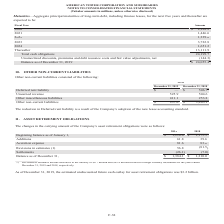According to American Tower Corporation's financial document, Why was there a reduction in the company's deferred rent liability? the Company’s adoption of the new lease accounting standard.. The document states: "eduction in Deferred rent liability is a result of the Company’s adoption of the new lease accounting standard...." Also, What was the deferred rent liability in 2018? According to the financial document, $506.7 (in millions). The relevant text states: "Deferred rent liability $ — $ 506.7..." Also, What was the Unearned revenue in 2019? According to the financial document, 525.9 (in millions). The relevant text states: "Unearned revenue 525.9 504.6..." Also, can you calculate: What was the change in unearned revenue between 2018 and 2019? Based on the calculation: 525.9-504.6, the result is 21.3 (in millions). This is based on the information: "Unearned revenue 525.9 504.6 Unearned revenue 525.9 504.6..." The key data points involved are: 504.6, 525.9. Also, How many of the non-current liabilities components in 2018 were above $500 million? Counting the relevant items in the document: Deferred rent liability, Unearned revenue, I find 2 instances (in millions). The key data points involved are: Deferred rent liability, Unearned revenue. Also, can you calculate: What was the percentage change between other non-current liabilities between 2018 and 2019? To answer this question, I need to perform calculations using the financial data. The calculation is: ($937.0-$1,265.1)/$1,265.1, which equals -25.93 (percentage). This is based on the information: "Other non-current liabilities $ 937.0 $ 1,265.1 Other non-current liabilities $ 937.0 $ 1,265.1..." The key data points involved are: 1,265.1, 937.0. 